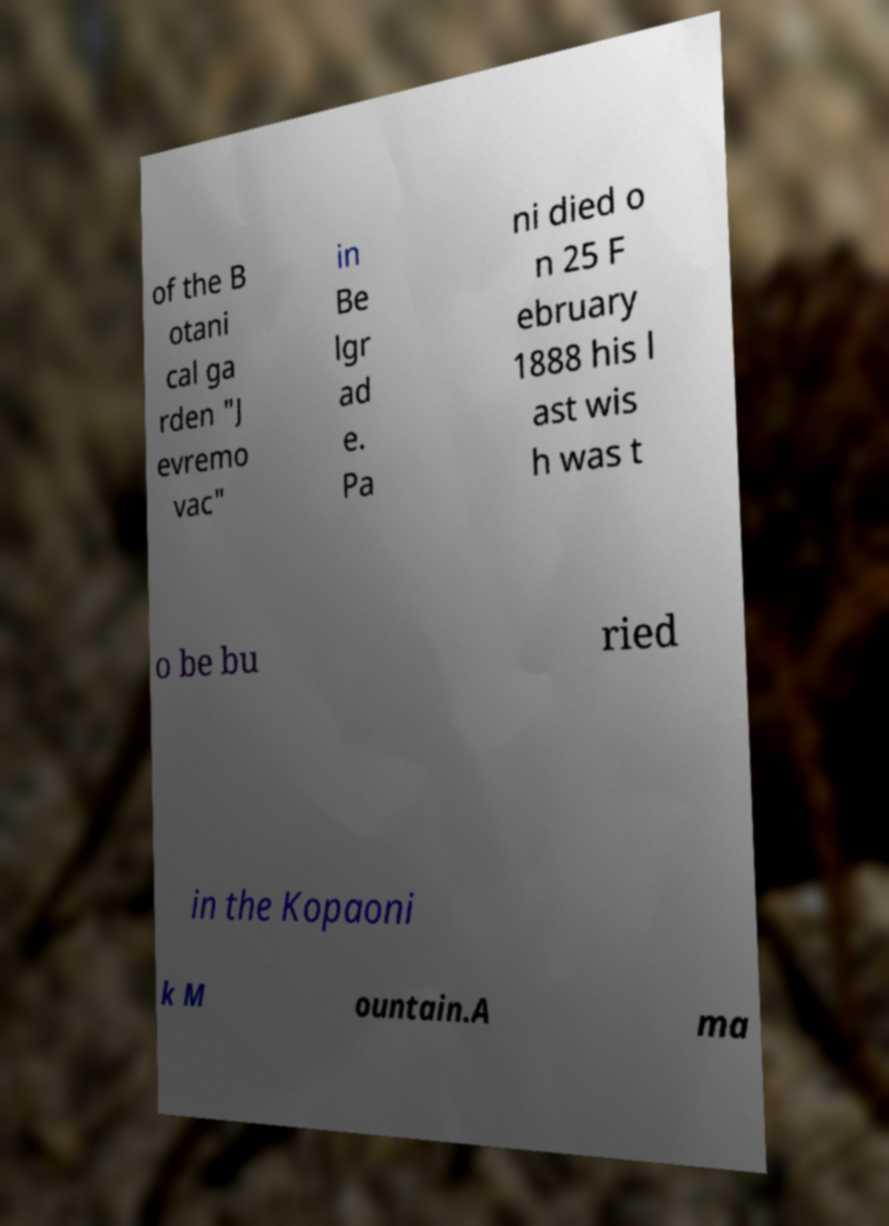Can you accurately transcribe the text from the provided image for me? of the B otani cal ga rden "J evremo vac" in Be lgr ad e. Pa ni died o n 25 F ebruary 1888 his l ast wis h was t o be bu ried in the Kopaoni k M ountain.A ma 